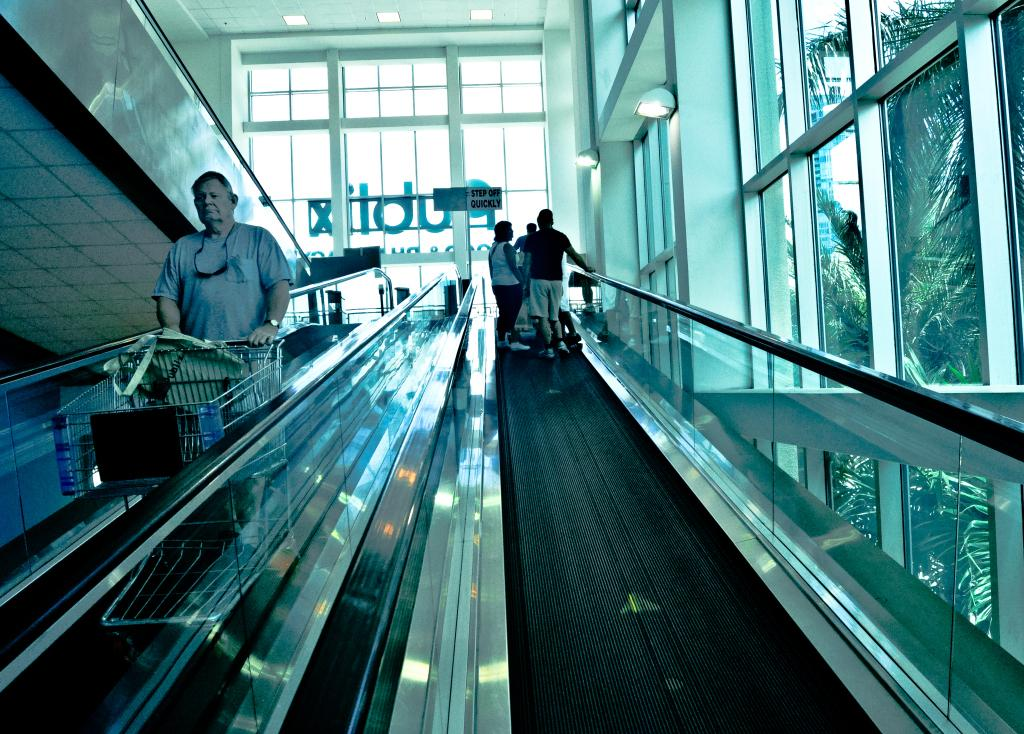<image>
Relay a brief, clear account of the picture shown. The Publix store has a large escalator which accommodates grocery carts. 